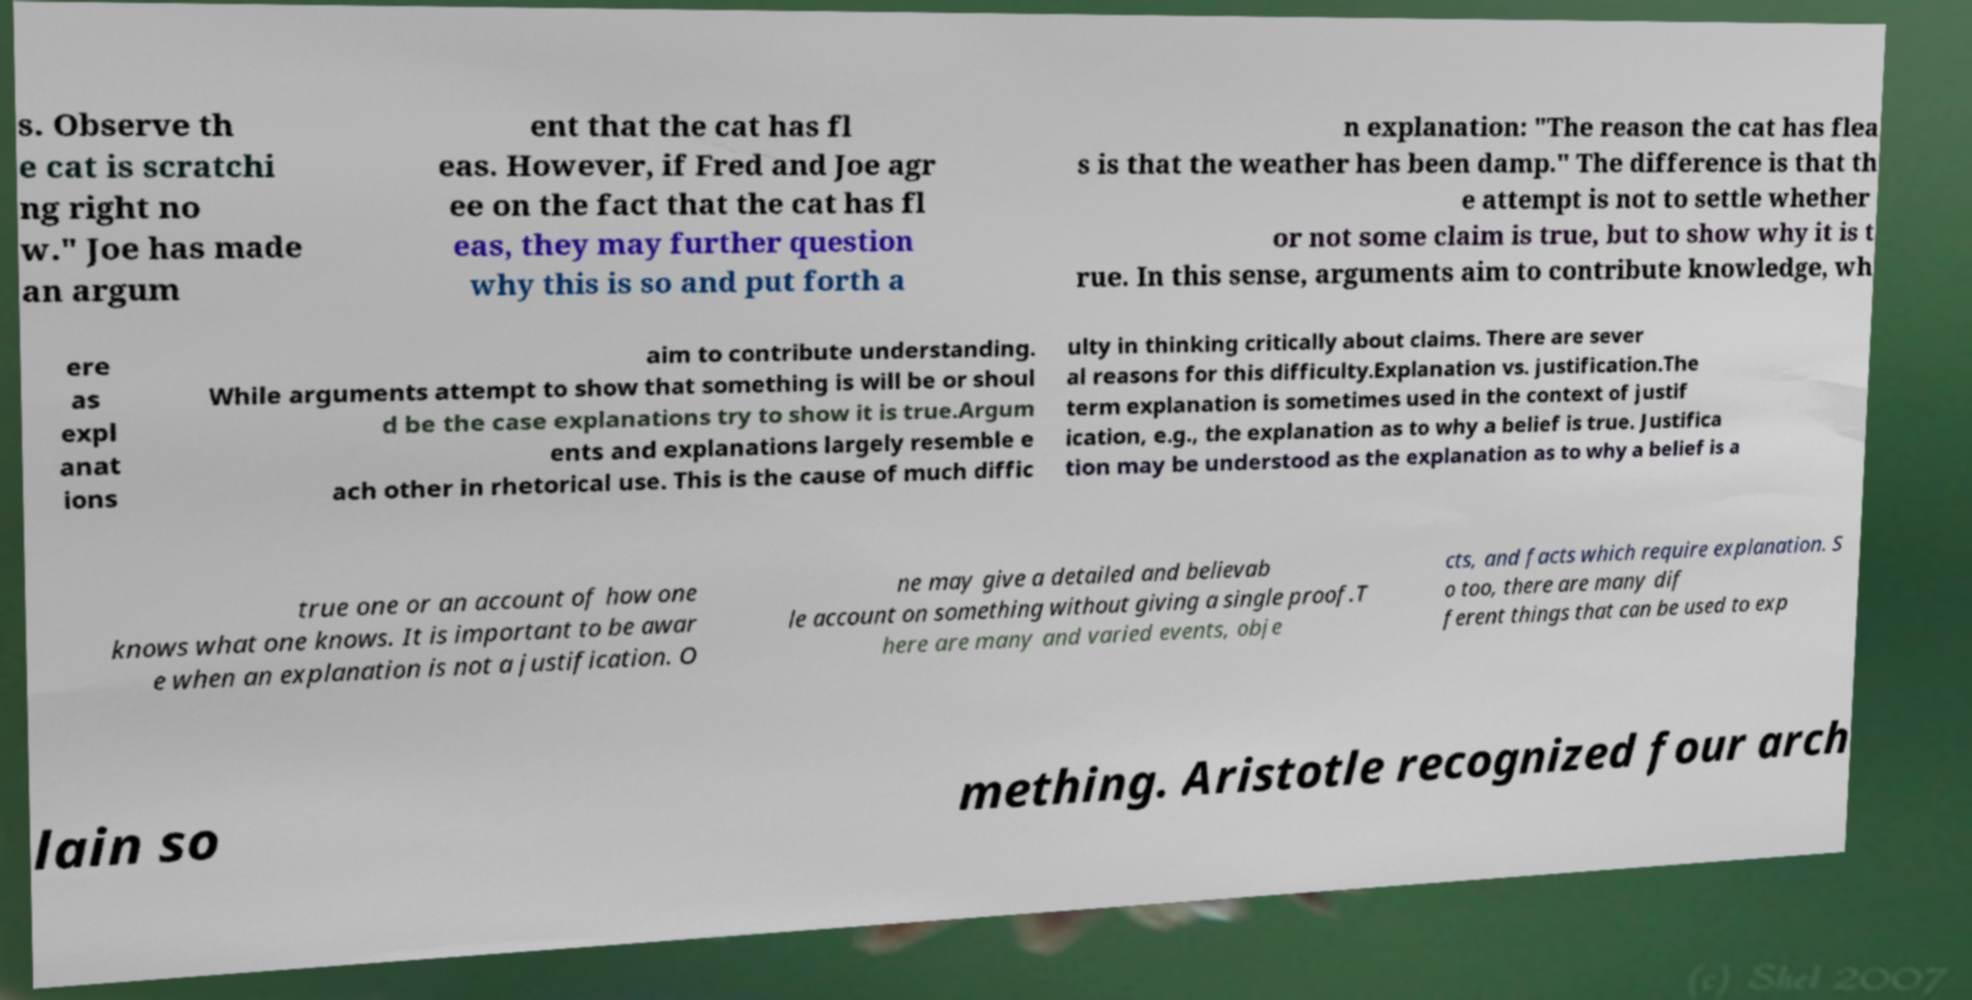What messages or text are displayed in this image? I need them in a readable, typed format. s. Observe th e cat is scratchi ng right no w." Joe has made an argum ent that the cat has fl eas. However, if Fred and Joe agr ee on the fact that the cat has fl eas, they may further question why this is so and put forth a n explanation: "The reason the cat has flea s is that the weather has been damp." The difference is that th e attempt is not to settle whether or not some claim is true, but to show why it is t rue. In this sense, arguments aim to contribute knowledge, wh ere as expl anat ions aim to contribute understanding. While arguments attempt to show that something is will be or shoul d be the case explanations try to show it is true.Argum ents and explanations largely resemble e ach other in rhetorical use. This is the cause of much diffic ulty in thinking critically about claims. There are sever al reasons for this difficulty.Explanation vs. justification.The term explanation is sometimes used in the context of justif ication, e.g., the explanation as to why a belief is true. Justifica tion may be understood as the explanation as to why a belief is a true one or an account of how one knows what one knows. It is important to be awar e when an explanation is not a justification. O ne may give a detailed and believab le account on something without giving a single proof.T here are many and varied events, obje cts, and facts which require explanation. S o too, there are many dif ferent things that can be used to exp lain so mething. Aristotle recognized four arch 